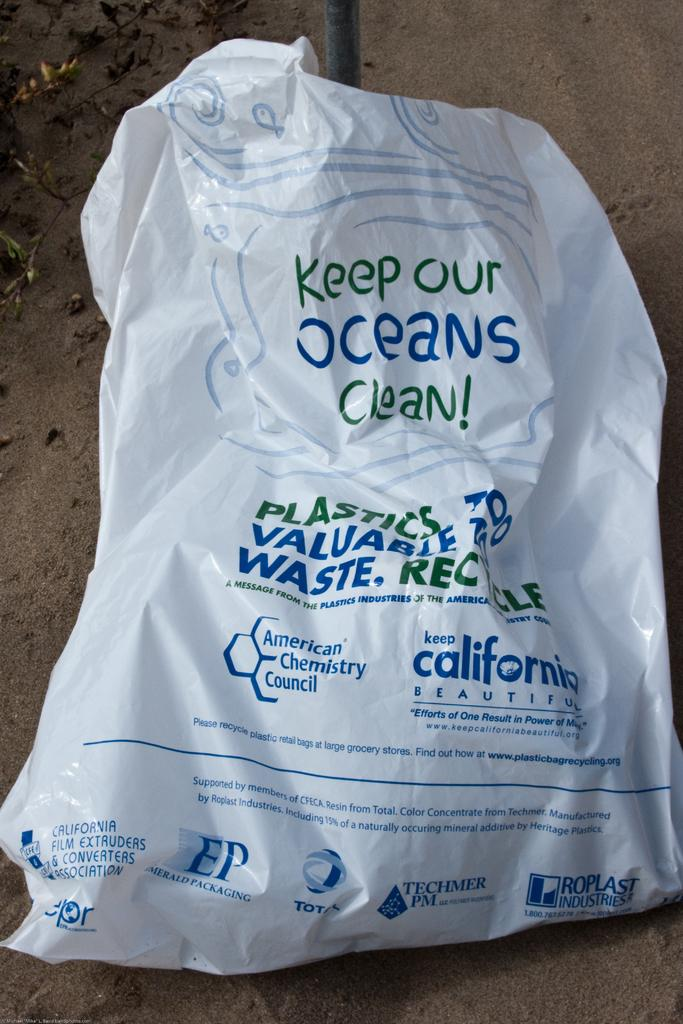What type of material is the cover in the image made of? The cover in the image is made of plastic. What can be found on the plastic cover? There is printed text on the plastic cover. What type of terrain is visible in the image? The image contains sand. What is the tall, metal object in the image? There is an iron pole in the image. What type of bat is flying over the sand in the image? There is no bat present in the image; it only contains a plastic cover, printed text, sand, and an iron pole. 